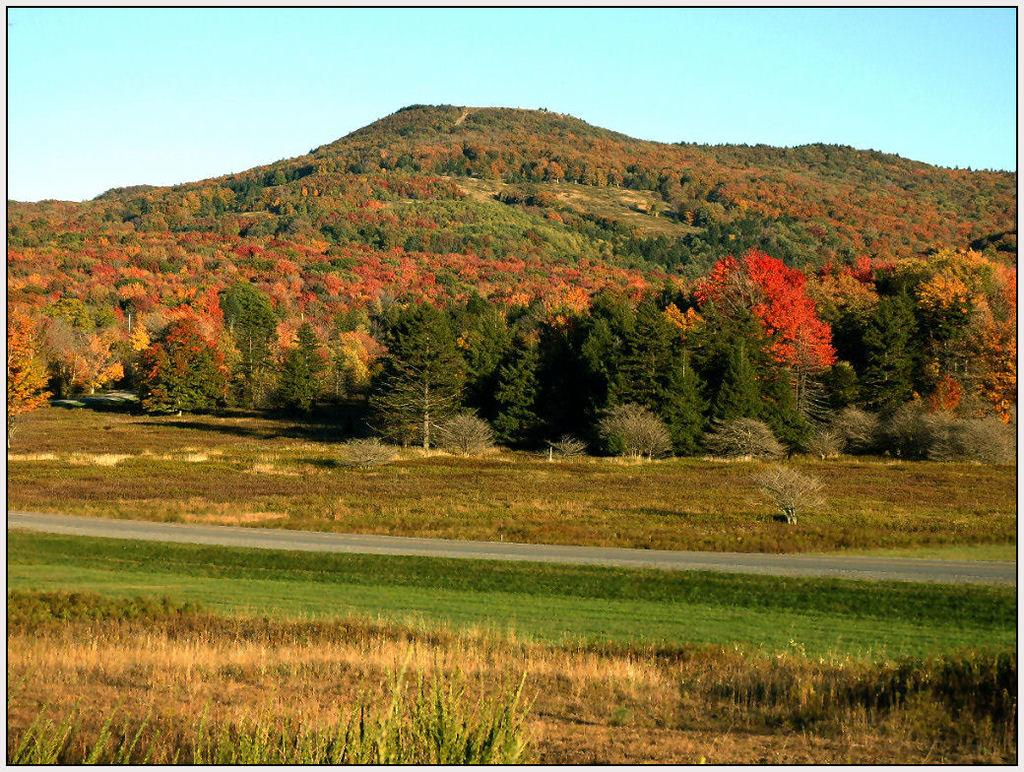What can be seen in the foreground of the image? There are plants and grass in the foreground of the image. What is located in the middle of the image? There is a path in the middle of the image. What is visible in the background of the image? There are trees on a cliff in the background of the image. What is visible at the top of the image? The sky is visible at the top of the image. What type of wristwatch is the son wearing in the image? There is no son or wristwatch present in the image. What is the wealth status of the person in the image? There is no information about the wealth status of any person in the image. 